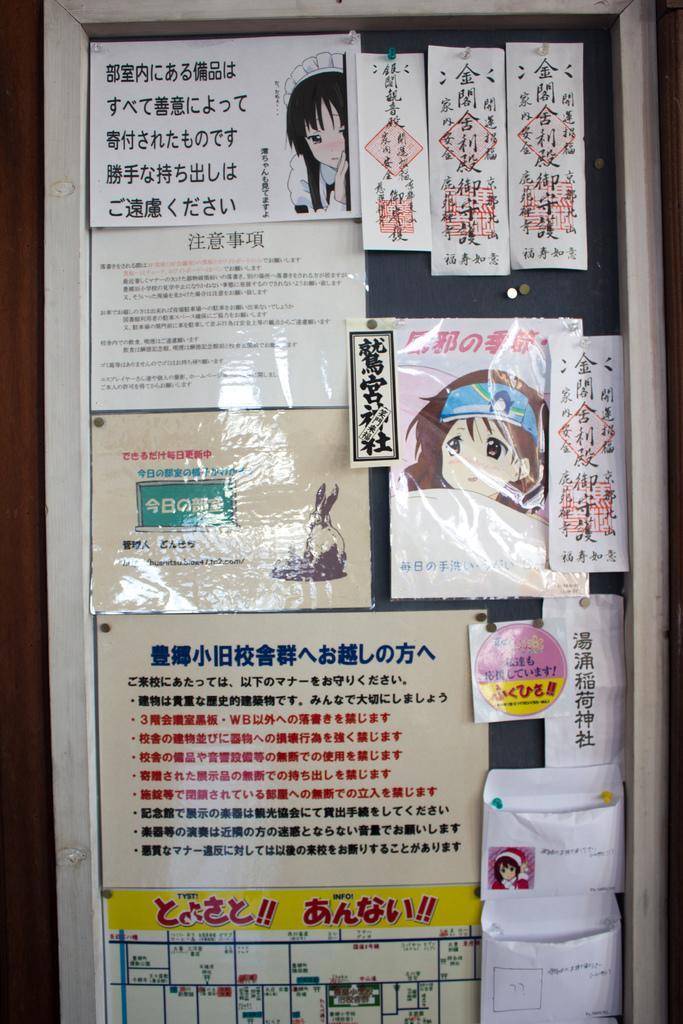Please provide a concise description of this image. In this image there is a board with many papers and posters on it. There is a text on the papers and there are a few images on the posters. 